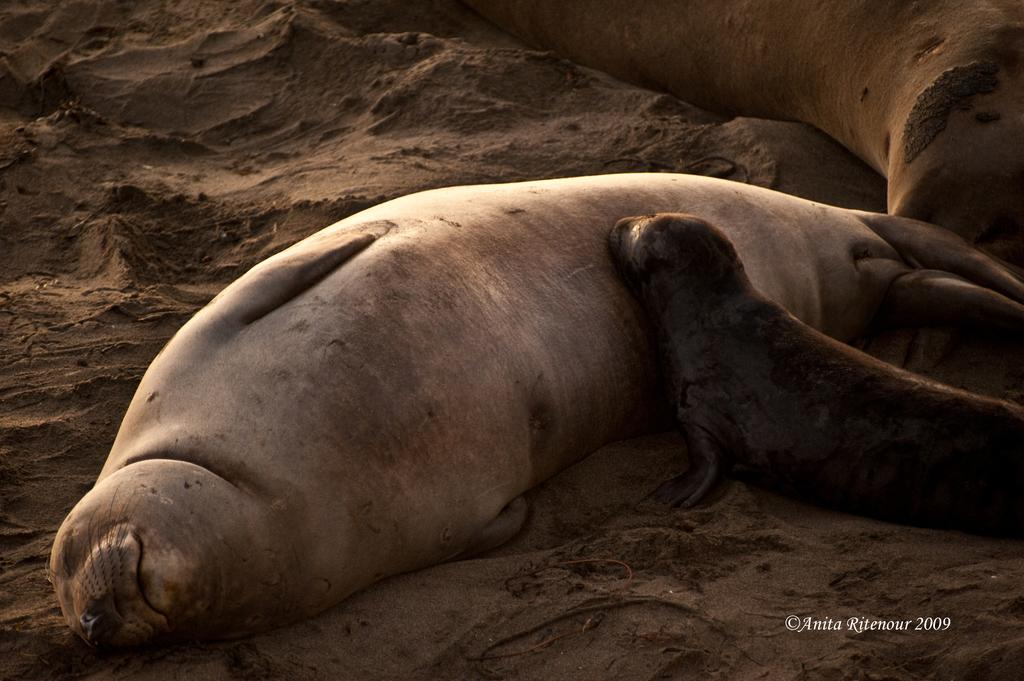What animal is in the center of the image? There is a seal in the center of the image. What is the condition of the area where the seal is located? The seal is on a muddy area. Are there any other seals visible in the image? Yes, there is another seal on the right side of the image. What type of respect can be seen in the image? There is no indication of respect in the image; it features two seals in a muddy area. What story is being told by the seals in the image? There is no story being told by the seals in the image; they are simply depicted in their natural environment. 